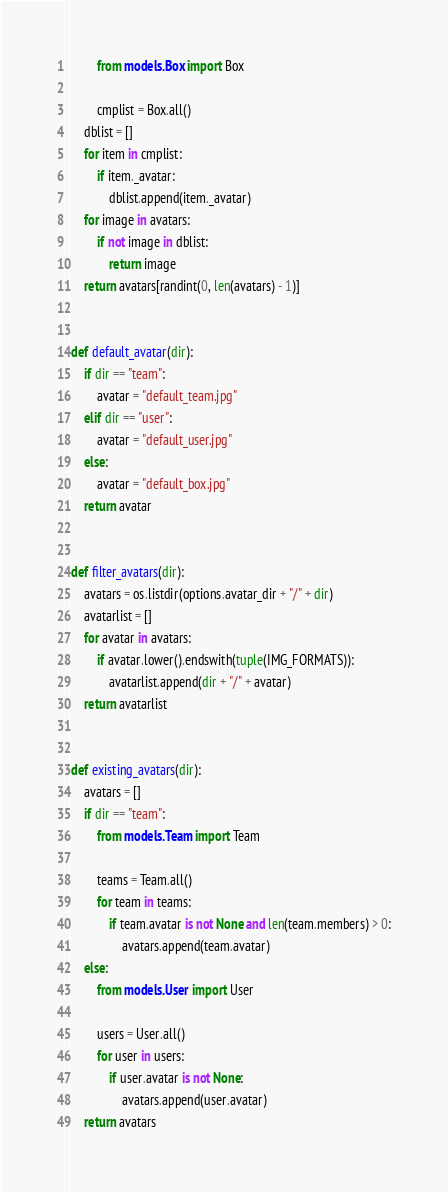<code> <loc_0><loc_0><loc_500><loc_500><_Python_>        from models.Box import Box

        cmplist = Box.all()
    dblist = []
    for item in cmplist:
        if item._avatar:
            dblist.append(item._avatar)
    for image in avatars:
        if not image in dblist:
            return image
    return avatars[randint(0, len(avatars) - 1)]


def default_avatar(dir):
    if dir == "team":
        avatar = "default_team.jpg"
    elif dir == "user":
        avatar = "default_user.jpg"
    else:
        avatar = "default_box.jpg"
    return avatar


def filter_avatars(dir):
    avatars = os.listdir(options.avatar_dir + "/" + dir)
    avatarlist = []
    for avatar in avatars:
        if avatar.lower().endswith(tuple(IMG_FORMATS)):
            avatarlist.append(dir + "/" + avatar)
    return avatarlist


def existing_avatars(dir):
    avatars = []
    if dir == "team":
        from models.Team import Team

        teams = Team.all()
        for team in teams:
            if team.avatar is not None and len(team.members) > 0:
                avatars.append(team.avatar)
    else:
        from models.User import User

        users = User.all()
        for user in users:
            if user.avatar is not None:
                avatars.append(user.avatar)
    return avatars
</code> 